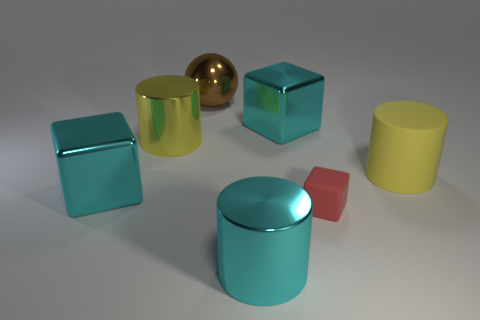Subtract all shiny blocks. How many blocks are left? 1 Subtract all yellow cylinders. How many cylinders are left? 1 Add 2 purple cylinders. How many objects exist? 9 Subtract all cubes. How many objects are left? 4 Subtract all yellow cylinders. How many red blocks are left? 1 Add 5 small red matte blocks. How many small red matte blocks are left? 6 Add 6 cyan metal things. How many cyan metal things exist? 9 Subtract 1 brown spheres. How many objects are left? 6 Subtract 1 balls. How many balls are left? 0 Subtract all purple spheres. Subtract all red cylinders. How many spheres are left? 1 